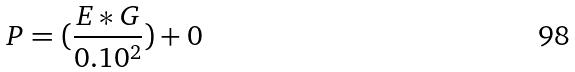<formula> <loc_0><loc_0><loc_500><loc_500>P = ( \frac { E * G } { 0 . 1 0 ^ { 2 } } ) + 0</formula> 